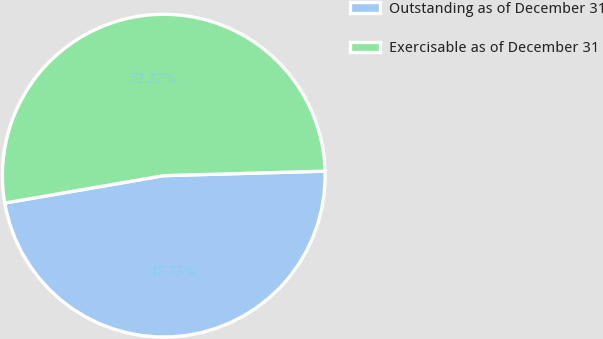Convert chart to OTSL. <chart><loc_0><loc_0><loc_500><loc_500><pie_chart><fcel>Outstanding as of December 31<fcel>Exercisable as of December 31<nl><fcel>47.73%<fcel>52.27%<nl></chart> 